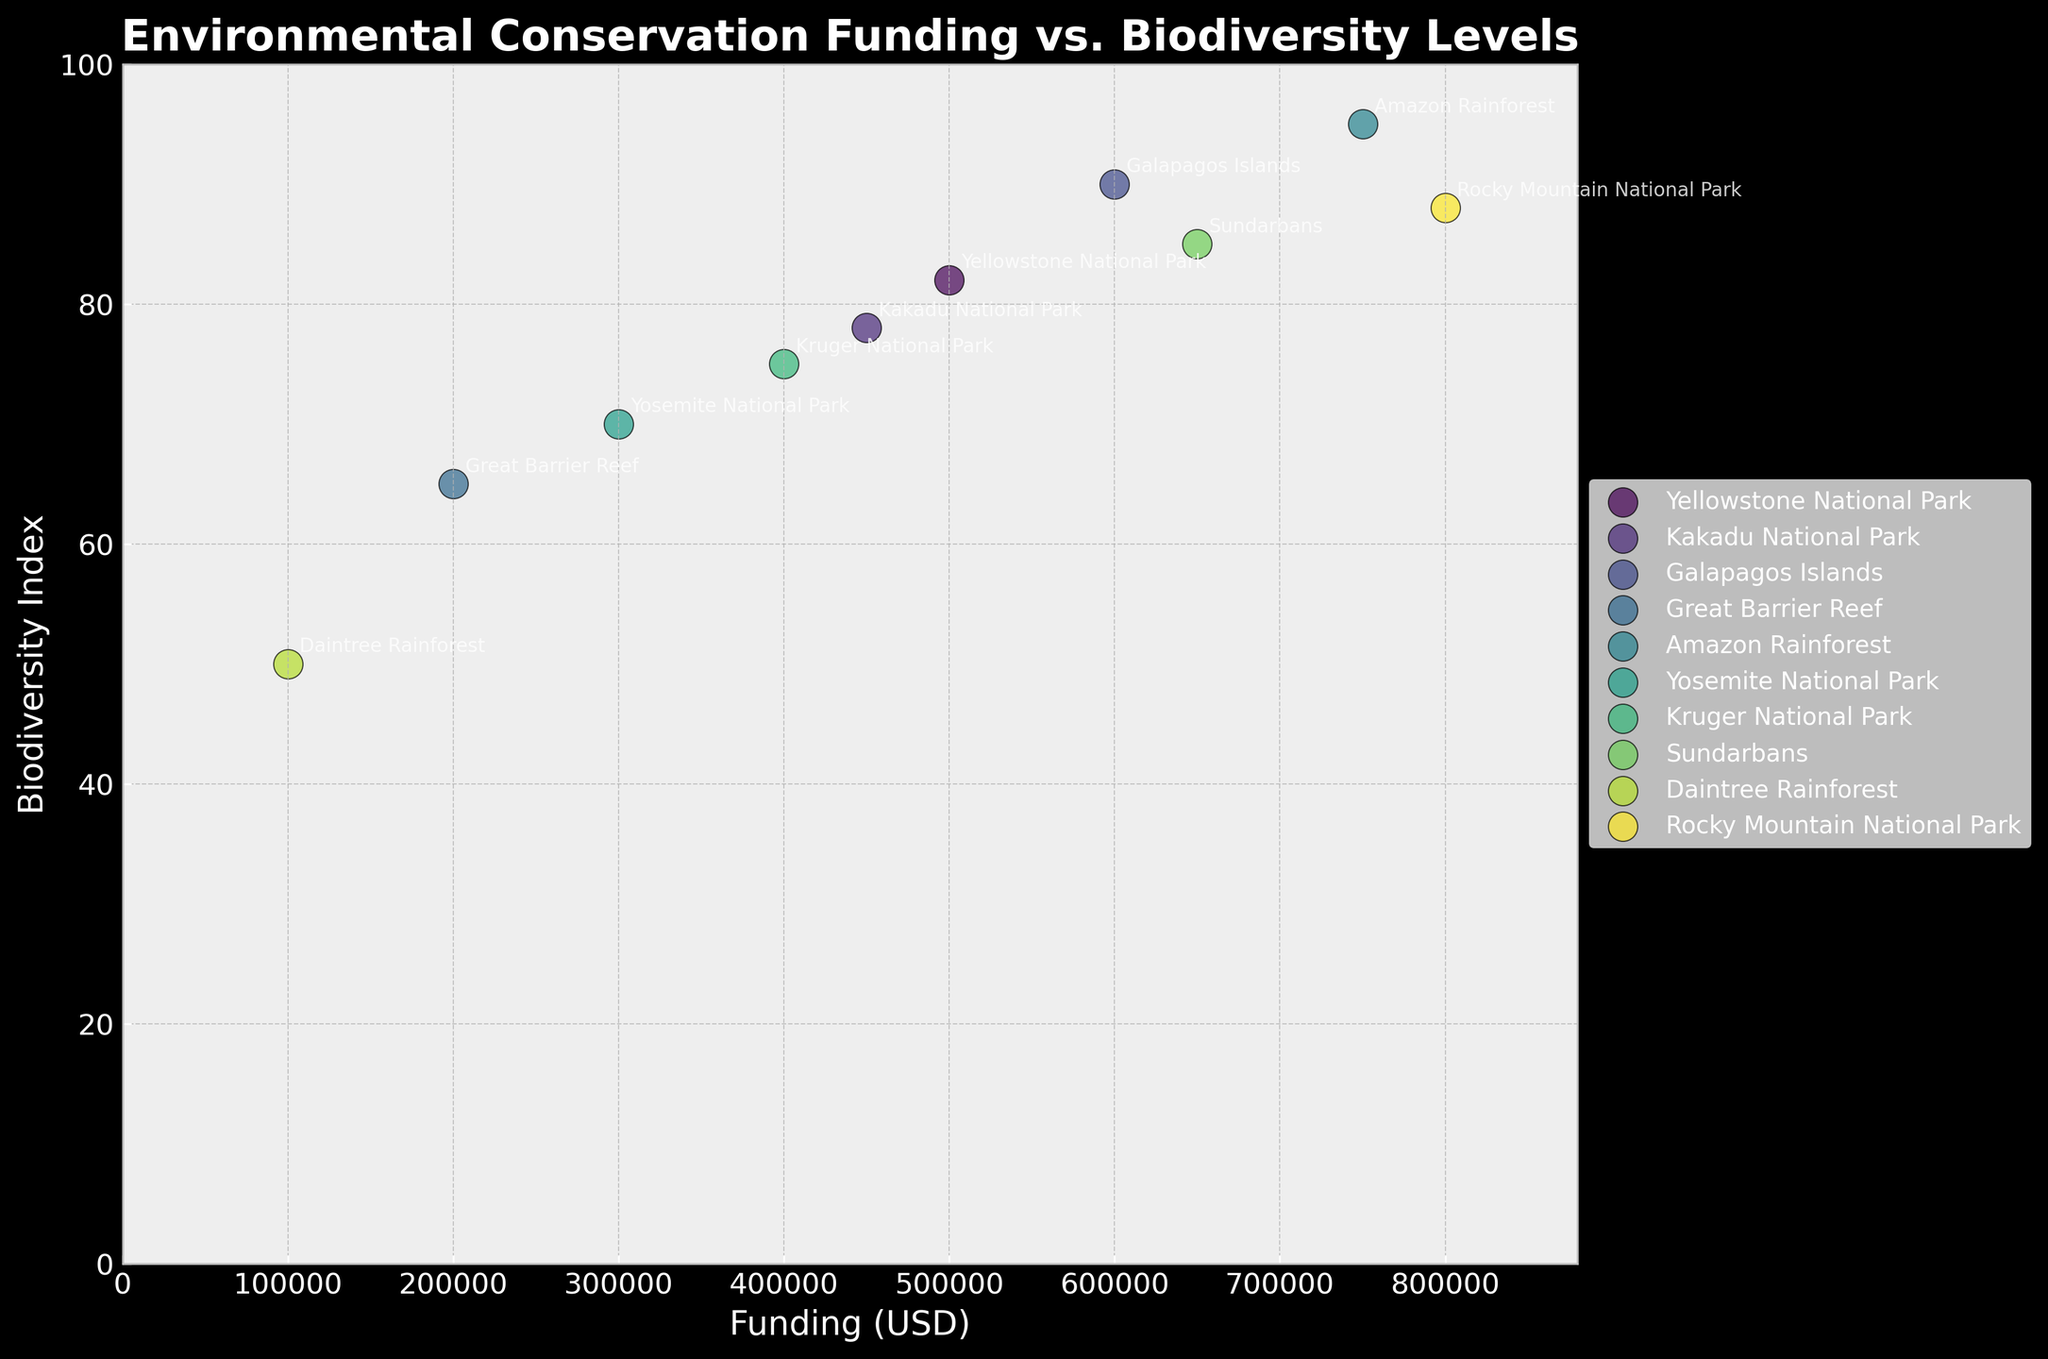Which protected area received the highest funding? The point on the far right corresponds to the highest funding. Based on the annotation, it is Rocky Mountain National Park.
Answer: Rocky Mountain National Park What is the title of the plot? The title is shown at the top of the plot.
Answer: Environmental Conservation Funding vs. Biodiversity Levels Which protected area has the lowest biodiversity index? The point closest to the bottom on the graph represents the lowest biodiversity index, which is annotated as Daintree Rainforest.
Answer: Daintree Rainforest How many protected areas are represented in the plot? Each point represents a protected area, and there are annotations for each. Count these annotations. There are 10.
Answer: 10 Which location has higher biodiversity: Kakadu National Park or Kruger National Park? Compare the vertical positions of the points for Kakadu National Park and Kruger National Park. Kakadu is at 78, and Kruger is at 75.
Answer: Kakadu National Park Is there a general trend between funding and biodiversity index? Observe the overall direction of the points. Higher funding tends to correlate with a higher biodiversity index.
Answer: Yes What is the difference in biodiversity index between the Great Barrier Reef and Galapagos Islands? Find the vertical positions for the Great Barrier Reef and Galapagos Islands. Great Barrier Reef is at 65, Galapagos Islands at 90. The difference is 90 - 65.
Answer: 25 Which two locations have the closest biodiversity index? Compare the biodiversity indices and find the closest pair: Kruger National Park (75) and Kakadu National Park (78) are closest to each other.
Answer: Kruger National Park and Kakadu National Park What is the average biodiversity index of all the protected areas in the plot? Add all the biodiversity indices and divide by the number of points (82 + 78 + 90 + 65 + 95 + 70 + 75 + 85 + 50 + 88) / 10. This calculates to 77.8.
Answer: 77.8 Which location with more than $500,000 in funding has the lowest biodiversity index? Filter points with funding greater than $500,000 and compare their biodiversity indices. Sundarbans ($650,000, 85) and Rocky Mountain National Park ($800,000, 88) but Yellowstone National Park ($500,000, 82). The lowest in this range is Yellowstone National Park.
Answer: Yellowstone National Park 